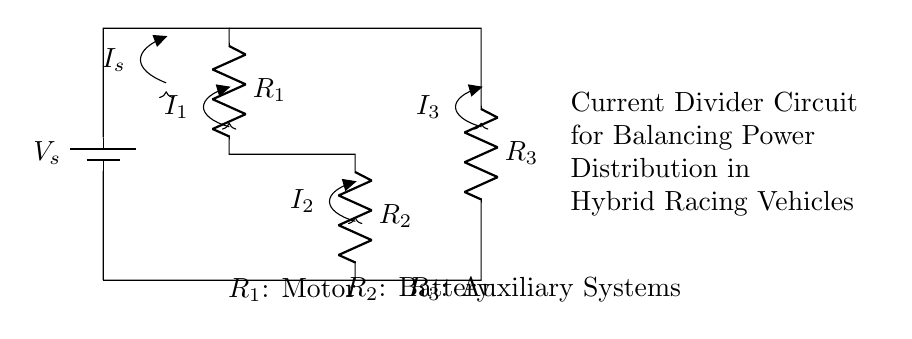What is the source voltage in the circuit? The source voltage is represented as Vs at the top of the circuit diagram, which is the potential difference provided by the battery.
Answer: Vs What type of components are R1, R2, and R3? R1, R2, and R3 are all resistors in the current divider circuit, indicating they are passive components that resist current flow.
Answer: Resistors How is the current divided among the resistors? The current divider principle states that the total current entering a junction splits among the parallel branches inversely to the resistance values, meaning lower resistance receives a larger current.
Answer: Inversely proportional to resistance What do R1, R2, and R3 each represent in this circuit? R1 represents the motor, R2 represents the battery, and R3 represents auxiliary systems, as stated in the labels placed below each resistor.
Answer: Motor, Battery, Auxiliary Systems What is the current entering the circuit? The current entering the circuit is denoted as Is, which indicates the total current supplied to the circuit from the battery before it is divided among R1, R2, and R3.
Answer: Is If R1 = 2 ohms, R2 = 3 ohms, and R3 = 5 ohms, which resistor will have the largest current? To find which resistor has the largest current, apply the current divider rule; since R1 has the lowest resistance (2 ohms), it will have the largest current flowing through it, making it the path of least resistance.
Answer: R1 